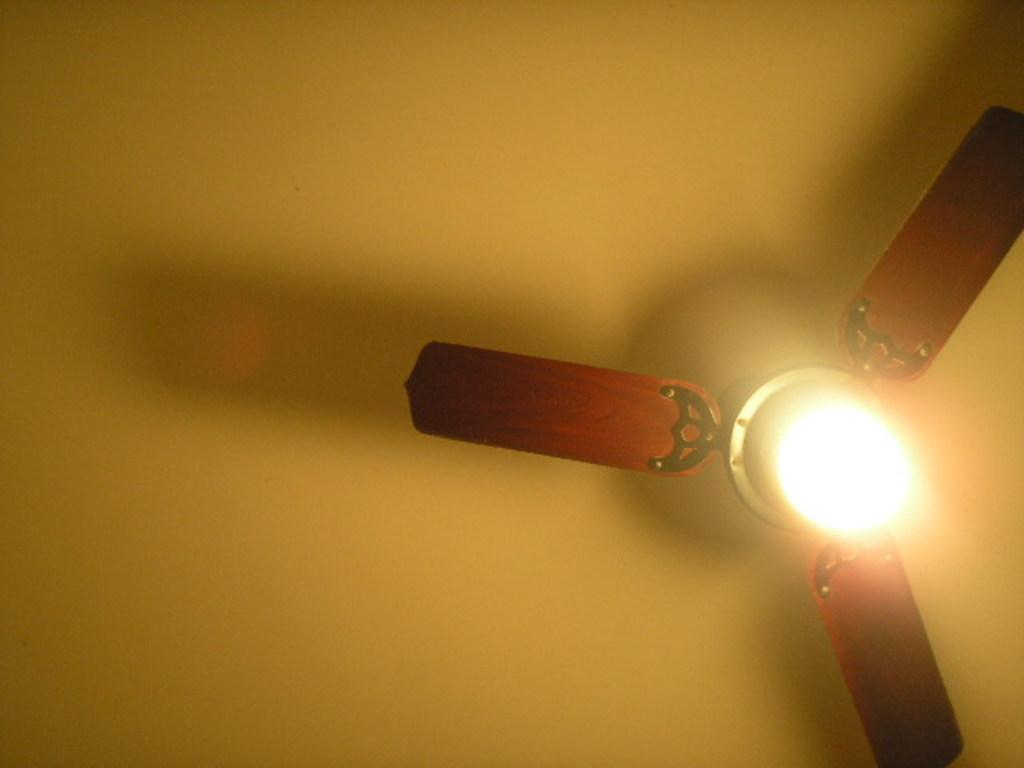What type of appliance is visible in the image? There is a fan in the image. What other object is near the fan? There is a light near the fan. Where are the fan and light located in the image? The fan and light are part of the ceiling. What shape is the girl in the image? There is no girl present in the image; it only features a fan and a light on the ceiling. 